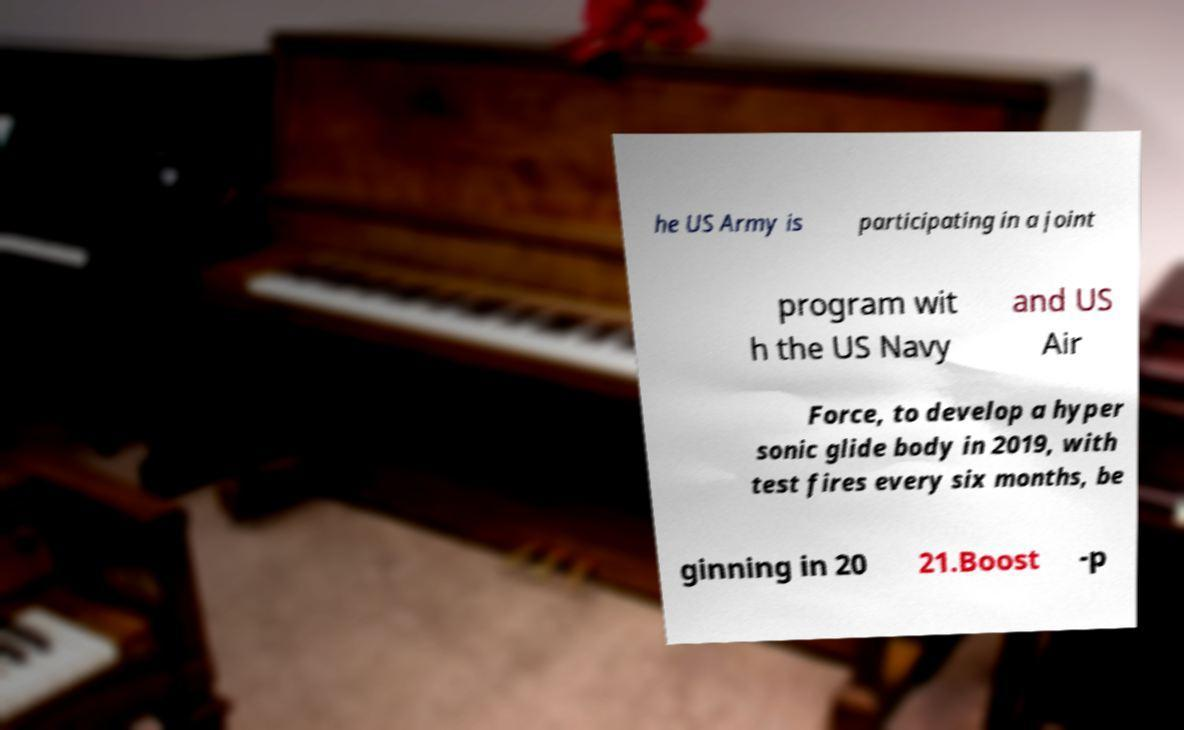For documentation purposes, I need the text within this image transcribed. Could you provide that? he US Army is participating in a joint program wit h the US Navy and US Air Force, to develop a hyper sonic glide body in 2019, with test fires every six months, be ginning in 20 21.Boost -p 